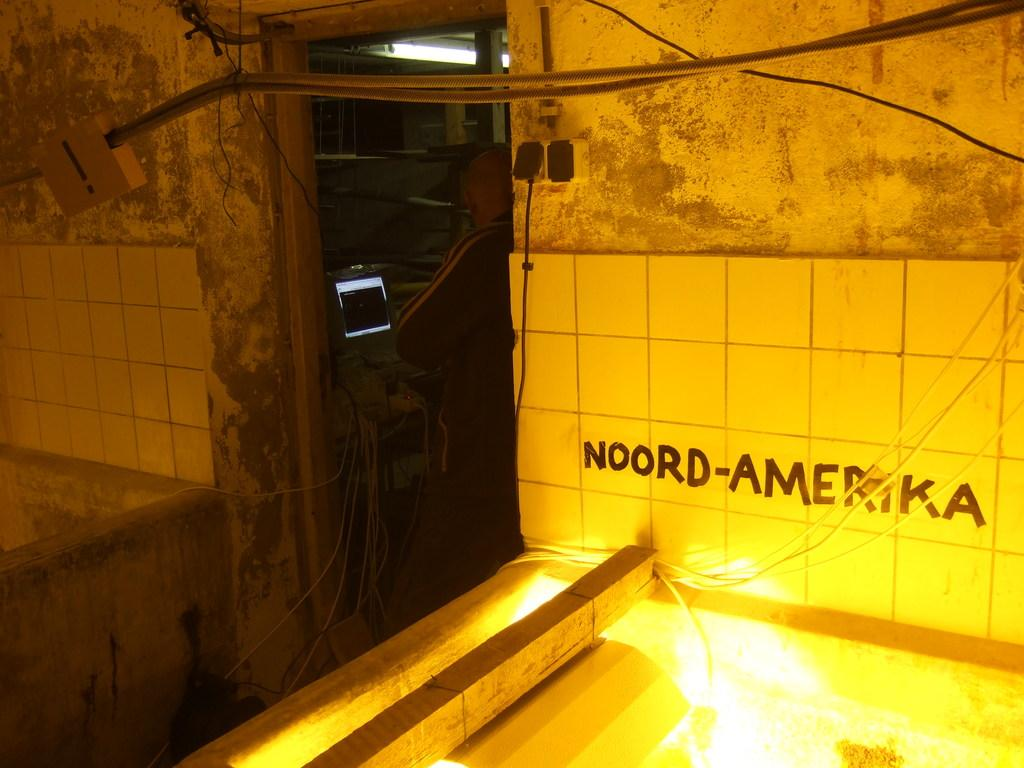What is the main object in the center of the image? There is a computer in the center of the image. Can you describe the person in the image? There is a person standing at the door. What can be seen on the right side of the image? There is a wire, a wall, and lights on the right side of the image. What type of plough is being used by the committee in the image? There is no plough or committee present in the image. How does the sleet affect the computer in the image? There is no mention of sleet in the image, and the computer appears to be unaffected by any weather conditions. 